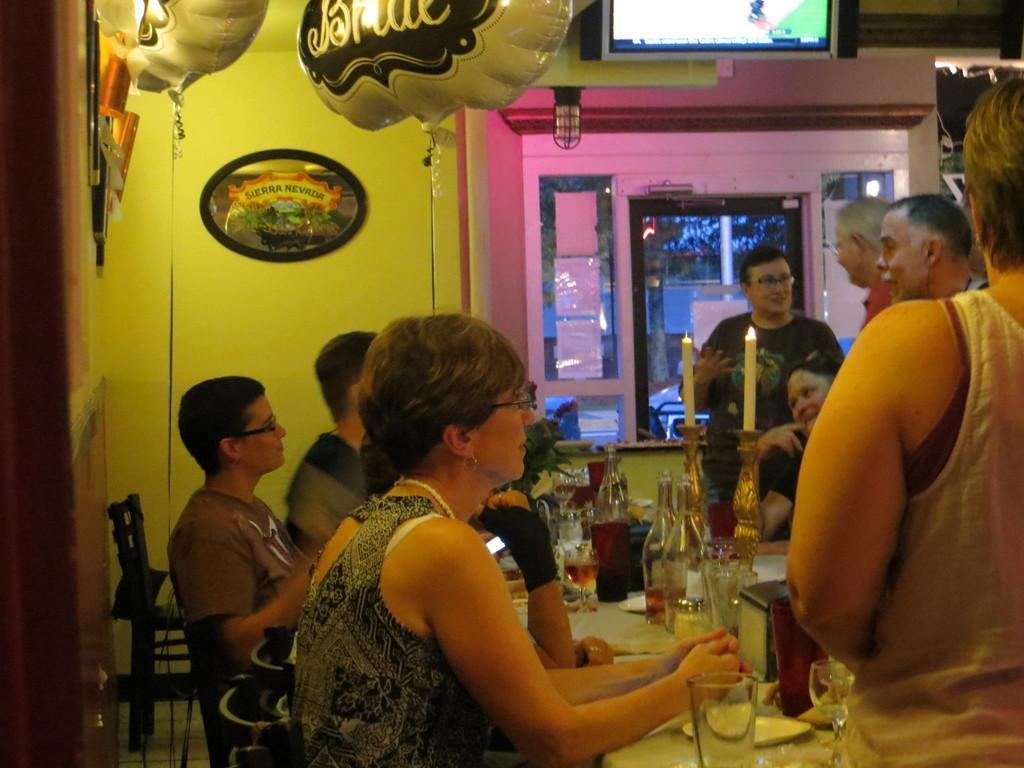Describe this image in one or two sentences. In this image, we can see a table, there are some glasses and bottles on the table. On the left side, we can see some people sitting on the chairs, On the right side, we can see some people standing. We can see some objects hanging, there is a television on the wall. 